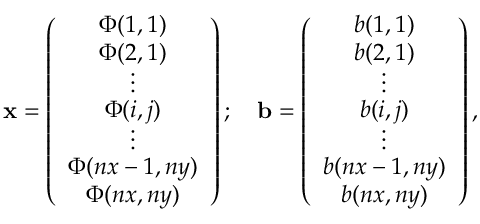<formula> <loc_0><loc_0><loc_500><loc_500>x = \left ( \begin{array} { c } { \Phi ( 1 , 1 ) } \\ { \Phi ( 2 , 1 ) } \\ { \vdots } \\ { \Phi ( i , j ) } \\ { \vdots } \\ { \Phi ( n x - 1 , n y ) } \\ { \Phi ( n x , n y ) } \end{array} \right ) ; \quad b = \left ( \begin{array} { c } { b ( 1 , 1 ) } \\ { b ( 2 , 1 ) } \\ { \vdots } \\ { b ( i , j ) } \\ { \vdots } \\ { b ( n x - 1 , n y ) } \\ { b ( n x , n y ) } \end{array} \right ) ,</formula> 